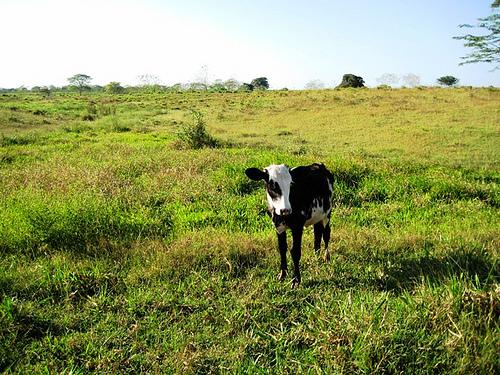Is this a free animal?
Write a very short answer. Yes. How many buildings are visible in the picture?
Short answer required. 0. Is this a zebra?
Answer briefly. No. 